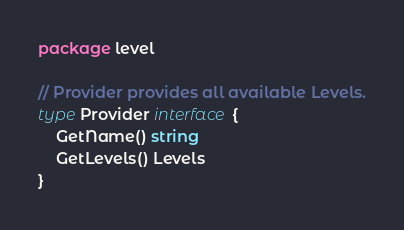<code> <loc_0><loc_0><loc_500><loc_500><_Go_>package level

// Provider provides all available Levels.
type Provider interface {
	GetName() string
	GetLevels() Levels
}
</code> 